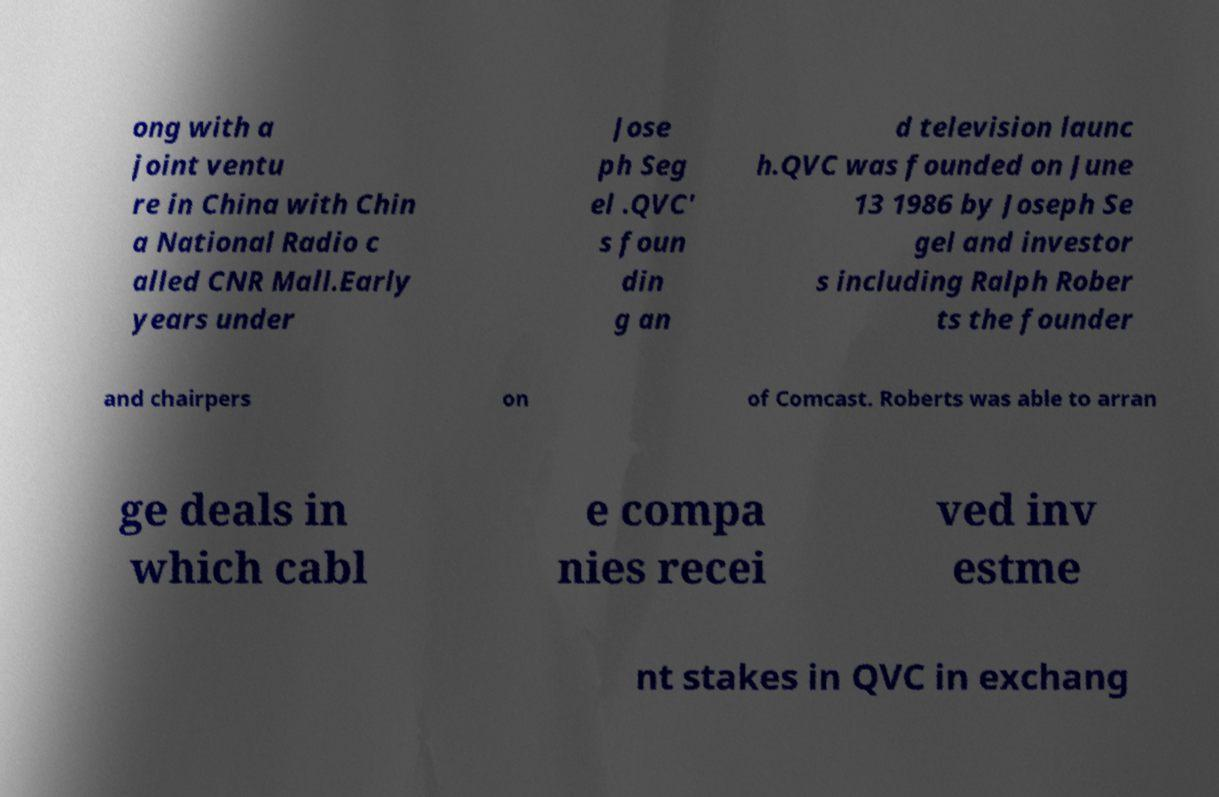I need the written content from this picture converted into text. Can you do that? ong with a joint ventu re in China with Chin a National Radio c alled CNR Mall.Early years under Jose ph Seg el .QVC' s foun din g an d television launc h.QVC was founded on June 13 1986 by Joseph Se gel and investor s including Ralph Rober ts the founder and chairpers on of Comcast. Roberts was able to arran ge deals in which cabl e compa nies recei ved inv estme nt stakes in QVC in exchang 